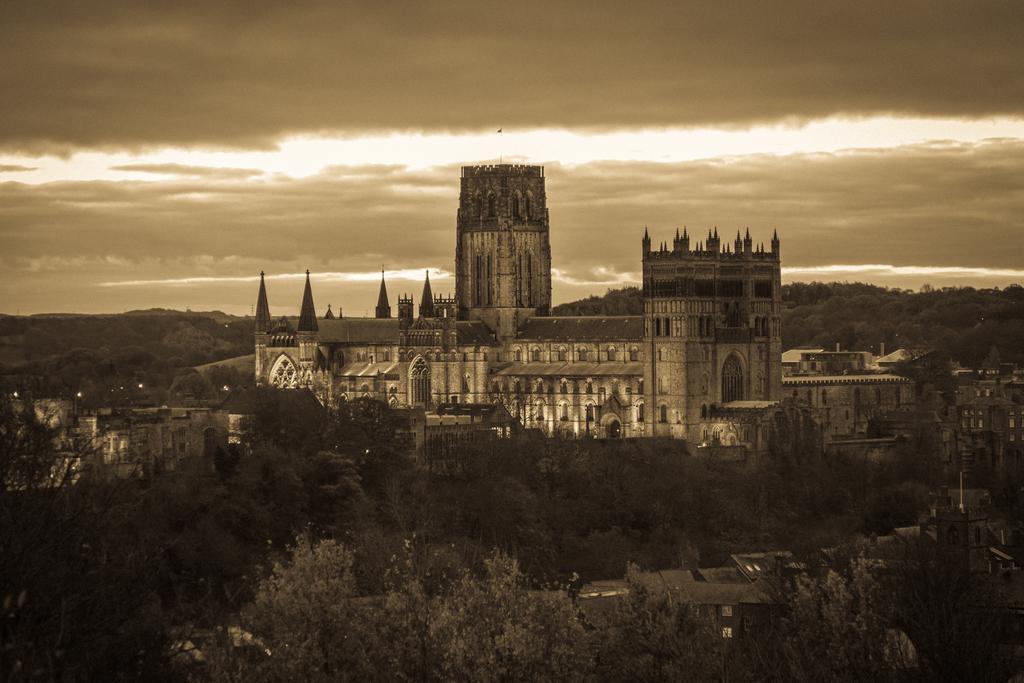Can you describe this image briefly? In this image I can see many trees, lights. At the back I can also see building, and sky is in gray color. 